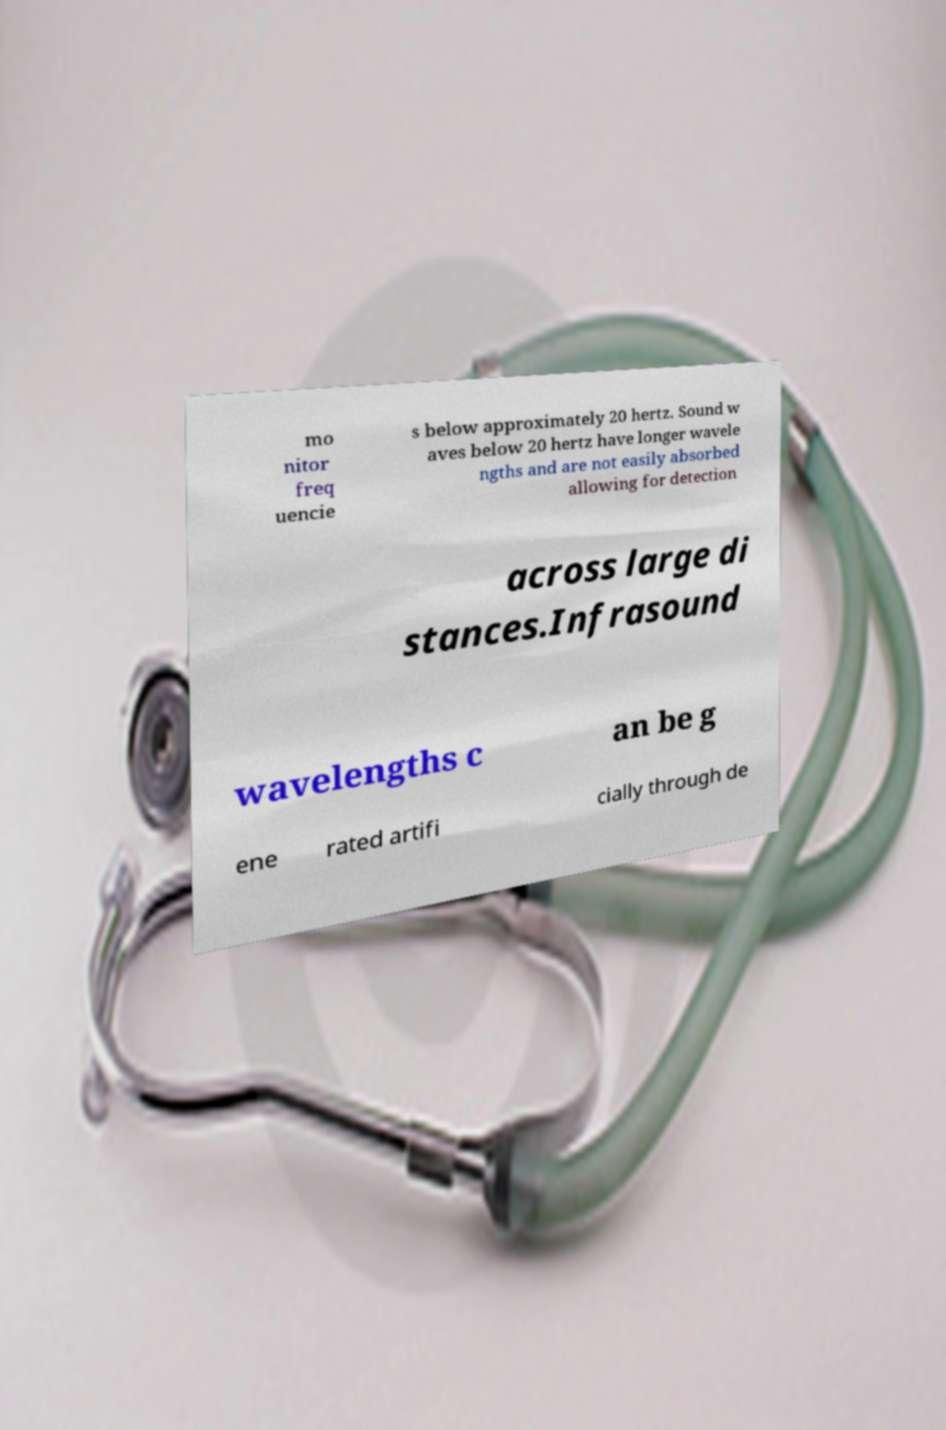Could you extract and type out the text from this image? mo nitor freq uencie s below approximately 20 hertz. Sound w aves below 20 hertz have longer wavele ngths and are not easily absorbed allowing for detection across large di stances.Infrasound wavelengths c an be g ene rated artifi cially through de 